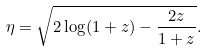Convert formula to latex. <formula><loc_0><loc_0><loc_500><loc_500>\eta = \sqrt { 2 \log ( 1 + z ) - \frac { 2 z } { 1 + z } } .</formula> 